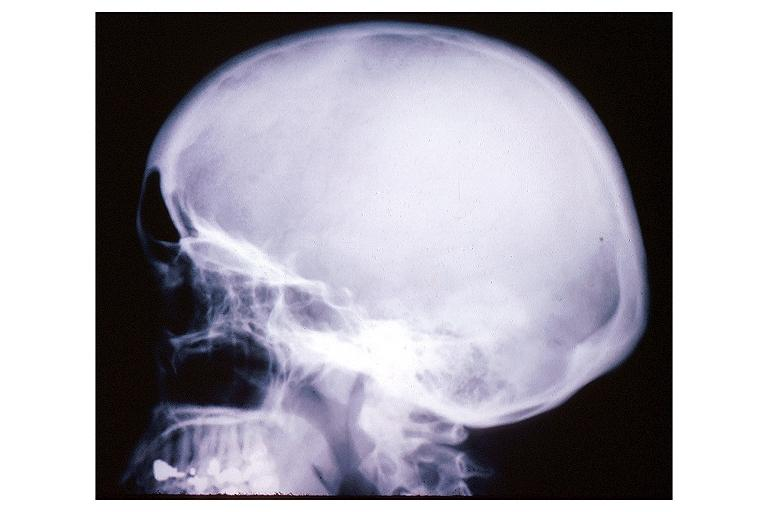does this image show pagets disease?
Answer the question using a single word or phrase. Yes 